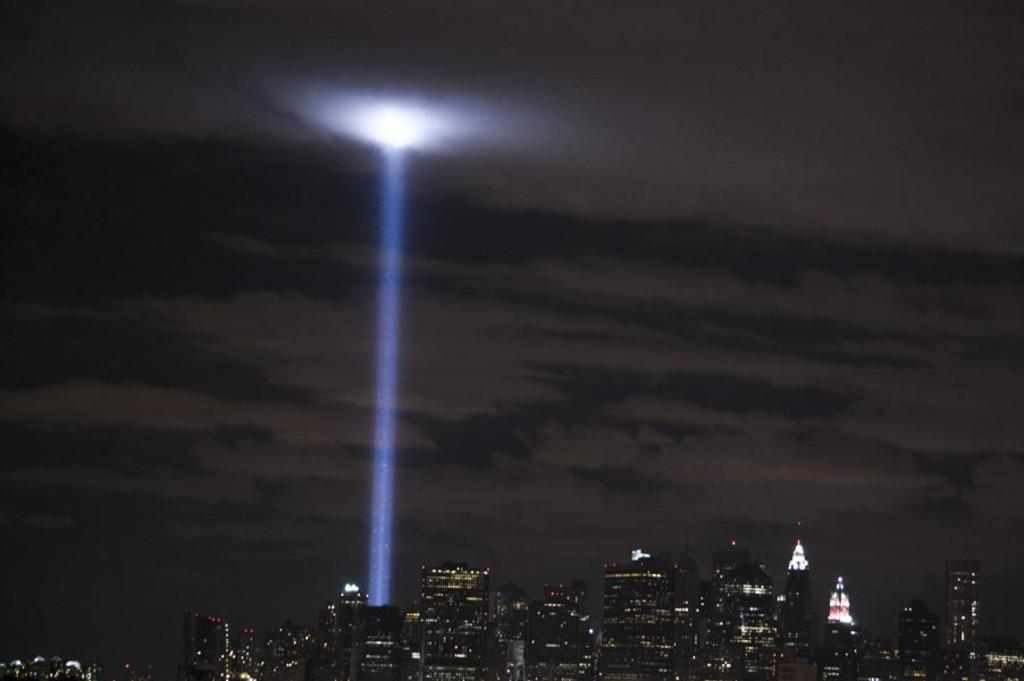What type of structures can be seen in the image? There are many buildings and skyscrapers in the image. What is the central feature of the image? There is a light ray in the middle of the image. What can be seen in the sky at the top of the image? There are clouds in the sky at the top of the image. Can you tell me how many yarn balls are hanging from the light ray in the image? There are no yarn balls present in the image; the light ray is not associated with any yarn. What type of cat can be seen swimming in the clouds in the image? There is no cat present in the image, and the clouds do not depict any swimming animals. 